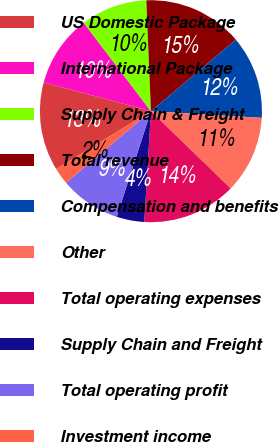<chart> <loc_0><loc_0><loc_500><loc_500><pie_chart><fcel>US Domestic Package<fcel>International Package<fcel>Supply Chain & Freight<fcel>Total revenue<fcel>Compensation and benefits<fcel>Other<fcel>Total operating expenses<fcel>Supply Chain and Freight<fcel>Total operating profit<fcel>Investment income<nl><fcel>12.9%<fcel>10.48%<fcel>9.68%<fcel>14.52%<fcel>12.1%<fcel>11.29%<fcel>13.71%<fcel>4.03%<fcel>8.87%<fcel>2.42%<nl></chart> 